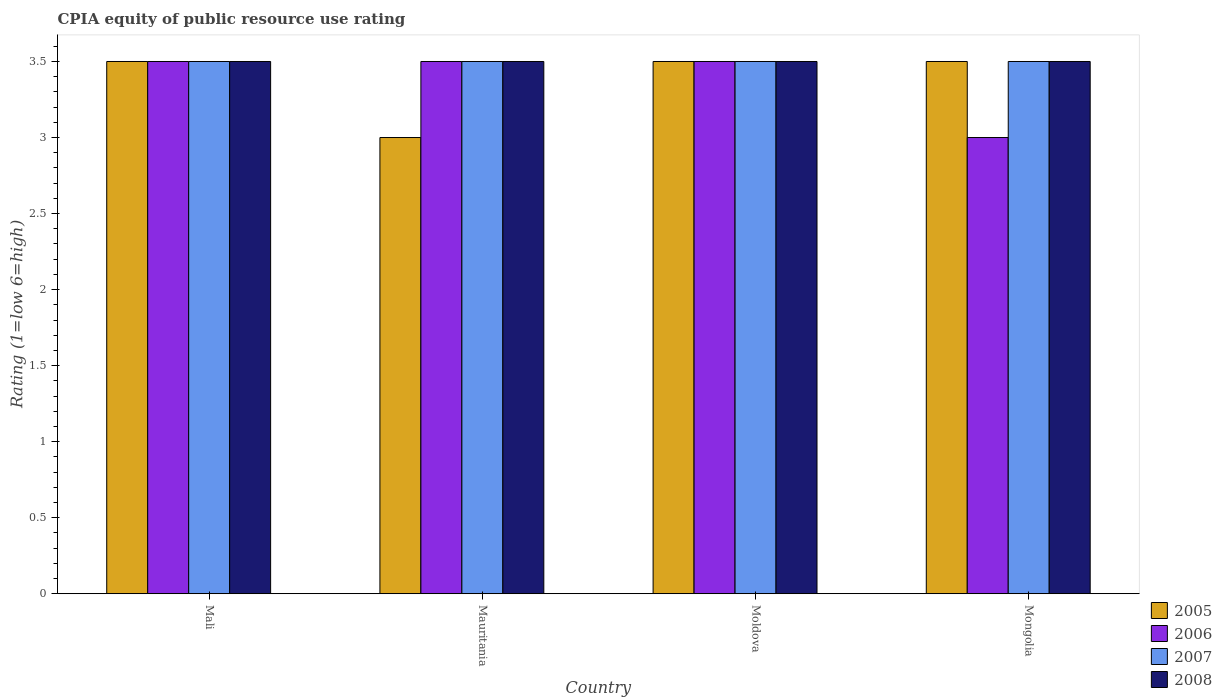How many different coloured bars are there?
Offer a very short reply. 4. How many bars are there on the 1st tick from the left?
Offer a terse response. 4. How many bars are there on the 3rd tick from the right?
Your response must be concise. 4. What is the label of the 4th group of bars from the left?
Provide a succinct answer. Mongolia. In how many cases, is the number of bars for a given country not equal to the number of legend labels?
Your answer should be compact. 0. What is the CPIA rating in 2005 in Moldova?
Your response must be concise. 3.5. In which country was the CPIA rating in 2008 maximum?
Give a very brief answer. Mali. In which country was the CPIA rating in 2007 minimum?
Ensure brevity in your answer.  Mali. What is the difference between the CPIA rating in 2006 in Mauritania and that in Moldova?
Your response must be concise. 0. What is the average CPIA rating in 2006 per country?
Make the answer very short. 3.38. What is the difference between the CPIA rating of/in 2006 and CPIA rating of/in 2005 in Mali?
Your answer should be very brief. 0. In how many countries, is the CPIA rating in 2006 greater than 1.5?
Offer a very short reply. 4. Is the difference between the CPIA rating in 2006 in Mali and Moldova greater than the difference between the CPIA rating in 2005 in Mali and Moldova?
Give a very brief answer. No. What is the difference between the highest and the lowest CPIA rating in 2005?
Your response must be concise. 0.5. In how many countries, is the CPIA rating in 2007 greater than the average CPIA rating in 2007 taken over all countries?
Make the answer very short. 0. Is it the case that in every country, the sum of the CPIA rating in 2008 and CPIA rating in 2007 is greater than the sum of CPIA rating in 2005 and CPIA rating in 2006?
Your answer should be very brief. No. What does the 2nd bar from the right in Moldova represents?
Provide a short and direct response. 2007. Is it the case that in every country, the sum of the CPIA rating in 2006 and CPIA rating in 2007 is greater than the CPIA rating in 2008?
Offer a very short reply. Yes. What is the difference between two consecutive major ticks on the Y-axis?
Offer a very short reply. 0.5. Are the values on the major ticks of Y-axis written in scientific E-notation?
Make the answer very short. No. Does the graph contain any zero values?
Give a very brief answer. No. Where does the legend appear in the graph?
Offer a very short reply. Bottom right. How many legend labels are there?
Your response must be concise. 4. What is the title of the graph?
Provide a short and direct response. CPIA equity of public resource use rating. What is the label or title of the X-axis?
Give a very brief answer. Country. What is the Rating (1=low 6=high) of 2005 in Mali?
Provide a short and direct response. 3.5. What is the Rating (1=low 6=high) in 2006 in Mali?
Offer a very short reply. 3.5. What is the Rating (1=low 6=high) of 2007 in Mali?
Make the answer very short. 3.5. What is the Rating (1=low 6=high) in 2005 in Mauritania?
Give a very brief answer. 3. What is the Rating (1=low 6=high) of 2006 in Mauritania?
Keep it short and to the point. 3.5. What is the Rating (1=low 6=high) in 2008 in Mauritania?
Offer a terse response. 3.5. What is the Rating (1=low 6=high) in 2005 in Moldova?
Give a very brief answer. 3.5. What is the Rating (1=low 6=high) of 2005 in Mongolia?
Keep it short and to the point. 3.5. What is the Rating (1=low 6=high) of 2008 in Mongolia?
Your answer should be compact. 3.5. Across all countries, what is the minimum Rating (1=low 6=high) of 2005?
Give a very brief answer. 3. Across all countries, what is the minimum Rating (1=low 6=high) in 2007?
Your response must be concise. 3.5. Across all countries, what is the minimum Rating (1=low 6=high) of 2008?
Your answer should be very brief. 3.5. What is the total Rating (1=low 6=high) in 2005 in the graph?
Offer a terse response. 13.5. What is the total Rating (1=low 6=high) of 2006 in the graph?
Your answer should be very brief. 13.5. What is the total Rating (1=low 6=high) of 2007 in the graph?
Your answer should be compact. 14. What is the total Rating (1=low 6=high) of 2008 in the graph?
Provide a succinct answer. 14. What is the difference between the Rating (1=low 6=high) of 2006 in Mali and that in Moldova?
Offer a very short reply. 0. What is the difference between the Rating (1=low 6=high) in 2005 in Mali and that in Mongolia?
Give a very brief answer. 0. What is the difference between the Rating (1=low 6=high) in 2006 in Mali and that in Mongolia?
Your answer should be very brief. 0.5. What is the difference between the Rating (1=low 6=high) of 2008 in Mali and that in Mongolia?
Keep it short and to the point. 0. What is the difference between the Rating (1=low 6=high) of 2008 in Mauritania and that in Moldova?
Ensure brevity in your answer.  0. What is the difference between the Rating (1=low 6=high) of 2005 in Mauritania and that in Mongolia?
Offer a terse response. -0.5. What is the difference between the Rating (1=low 6=high) of 2008 in Mauritania and that in Mongolia?
Your answer should be very brief. 0. What is the difference between the Rating (1=low 6=high) in 2005 in Moldova and that in Mongolia?
Your answer should be very brief. 0. What is the difference between the Rating (1=low 6=high) in 2005 in Mali and the Rating (1=low 6=high) in 2008 in Mauritania?
Your answer should be very brief. 0. What is the difference between the Rating (1=low 6=high) in 2006 in Mali and the Rating (1=low 6=high) in 2007 in Mauritania?
Provide a short and direct response. 0. What is the difference between the Rating (1=low 6=high) in 2007 in Mali and the Rating (1=low 6=high) in 2008 in Mauritania?
Your answer should be compact. 0. What is the difference between the Rating (1=low 6=high) in 2005 in Mali and the Rating (1=low 6=high) in 2007 in Moldova?
Offer a very short reply. 0. What is the difference between the Rating (1=low 6=high) in 2005 in Mali and the Rating (1=low 6=high) in 2008 in Moldova?
Provide a succinct answer. 0. What is the difference between the Rating (1=low 6=high) of 2006 in Mali and the Rating (1=low 6=high) of 2007 in Moldova?
Keep it short and to the point. 0. What is the difference between the Rating (1=low 6=high) in 2005 in Mali and the Rating (1=low 6=high) in 2006 in Mongolia?
Give a very brief answer. 0.5. What is the difference between the Rating (1=low 6=high) in 2006 in Mali and the Rating (1=low 6=high) in 2007 in Mongolia?
Your answer should be very brief. 0. What is the difference between the Rating (1=low 6=high) in 2007 in Mali and the Rating (1=low 6=high) in 2008 in Mongolia?
Offer a terse response. 0. What is the difference between the Rating (1=low 6=high) of 2005 in Mauritania and the Rating (1=low 6=high) of 2007 in Moldova?
Keep it short and to the point. -0.5. What is the difference between the Rating (1=low 6=high) in 2006 in Mauritania and the Rating (1=low 6=high) in 2008 in Moldova?
Give a very brief answer. 0. What is the difference between the Rating (1=low 6=high) in 2007 in Mauritania and the Rating (1=low 6=high) in 2008 in Moldova?
Give a very brief answer. 0. What is the difference between the Rating (1=low 6=high) in 2005 in Mauritania and the Rating (1=low 6=high) in 2006 in Mongolia?
Offer a very short reply. 0. What is the difference between the Rating (1=low 6=high) in 2005 in Mauritania and the Rating (1=low 6=high) in 2007 in Mongolia?
Provide a short and direct response. -0.5. What is the difference between the Rating (1=low 6=high) of 2006 in Mauritania and the Rating (1=low 6=high) of 2007 in Mongolia?
Make the answer very short. 0. What is the difference between the Rating (1=low 6=high) in 2005 in Moldova and the Rating (1=low 6=high) in 2006 in Mongolia?
Keep it short and to the point. 0.5. What is the difference between the Rating (1=low 6=high) in 2005 in Moldova and the Rating (1=low 6=high) in 2008 in Mongolia?
Your answer should be compact. 0. What is the average Rating (1=low 6=high) in 2005 per country?
Keep it short and to the point. 3.38. What is the average Rating (1=low 6=high) of 2006 per country?
Give a very brief answer. 3.38. What is the difference between the Rating (1=low 6=high) of 2005 and Rating (1=low 6=high) of 2007 in Mali?
Your response must be concise. 0. What is the difference between the Rating (1=low 6=high) of 2005 and Rating (1=low 6=high) of 2007 in Mauritania?
Provide a short and direct response. -0.5. What is the difference between the Rating (1=low 6=high) in 2006 and Rating (1=low 6=high) in 2007 in Mauritania?
Offer a terse response. 0. What is the difference between the Rating (1=low 6=high) of 2007 and Rating (1=low 6=high) of 2008 in Mauritania?
Keep it short and to the point. 0. What is the difference between the Rating (1=low 6=high) of 2005 and Rating (1=low 6=high) of 2007 in Moldova?
Offer a terse response. 0. What is the difference between the Rating (1=low 6=high) of 2006 and Rating (1=low 6=high) of 2008 in Moldova?
Provide a succinct answer. 0. What is the difference between the Rating (1=low 6=high) of 2007 and Rating (1=low 6=high) of 2008 in Moldova?
Offer a terse response. 0. What is the difference between the Rating (1=low 6=high) of 2005 and Rating (1=low 6=high) of 2006 in Mongolia?
Your response must be concise. 0.5. What is the difference between the Rating (1=low 6=high) of 2005 and Rating (1=low 6=high) of 2008 in Mongolia?
Make the answer very short. 0. What is the difference between the Rating (1=low 6=high) of 2006 and Rating (1=low 6=high) of 2007 in Mongolia?
Offer a terse response. -0.5. What is the difference between the Rating (1=low 6=high) of 2006 and Rating (1=low 6=high) of 2008 in Mongolia?
Your answer should be very brief. -0.5. What is the difference between the Rating (1=low 6=high) of 2007 and Rating (1=low 6=high) of 2008 in Mongolia?
Your answer should be compact. 0. What is the ratio of the Rating (1=low 6=high) in 2005 in Mali to that in Mauritania?
Your response must be concise. 1.17. What is the ratio of the Rating (1=low 6=high) of 2007 in Mali to that in Mauritania?
Keep it short and to the point. 1. What is the ratio of the Rating (1=low 6=high) of 2008 in Mali to that in Mauritania?
Provide a short and direct response. 1. What is the ratio of the Rating (1=low 6=high) in 2006 in Mali to that in Moldova?
Offer a very short reply. 1. What is the ratio of the Rating (1=low 6=high) of 2007 in Mali to that in Moldova?
Ensure brevity in your answer.  1. What is the ratio of the Rating (1=low 6=high) of 2005 in Mali to that in Mongolia?
Provide a succinct answer. 1. What is the ratio of the Rating (1=low 6=high) in 2007 in Mali to that in Mongolia?
Your answer should be compact. 1. What is the ratio of the Rating (1=low 6=high) of 2008 in Mali to that in Mongolia?
Your answer should be very brief. 1. What is the ratio of the Rating (1=low 6=high) of 2005 in Mauritania to that in Moldova?
Ensure brevity in your answer.  0.86. What is the ratio of the Rating (1=low 6=high) of 2007 in Mauritania to that in Moldova?
Ensure brevity in your answer.  1. What is the ratio of the Rating (1=low 6=high) of 2007 in Moldova to that in Mongolia?
Provide a short and direct response. 1. What is the difference between the highest and the second highest Rating (1=low 6=high) of 2005?
Your response must be concise. 0. What is the difference between the highest and the second highest Rating (1=low 6=high) in 2007?
Your response must be concise. 0. What is the difference between the highest and the lowest Rating (1=low 6=high) of 2006?
Offer a terse response. 0.5. 